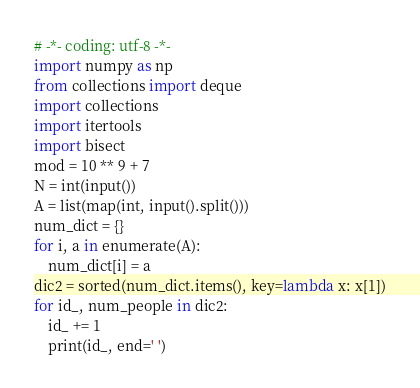Convert code to text. <code><loc_0><loc_0><loc_500><loc_500><_Python_># -*- coding: utf-8 -*-
import numpy as np
from collections import deque
import collections
import itertools
import bisect
mod = 10 ** 9 + 7
N = int(input())
A = list(map(int, input().split()))
num_dict = {}
for i, a in enumerate(A):
    num_dict[i] = a
dic2 = sorted(num_dict.items(), key=lambda x: x[1])
for id_, num_people in dic2:
    id_ += 1
    print(id_, end=' ')
</code> 